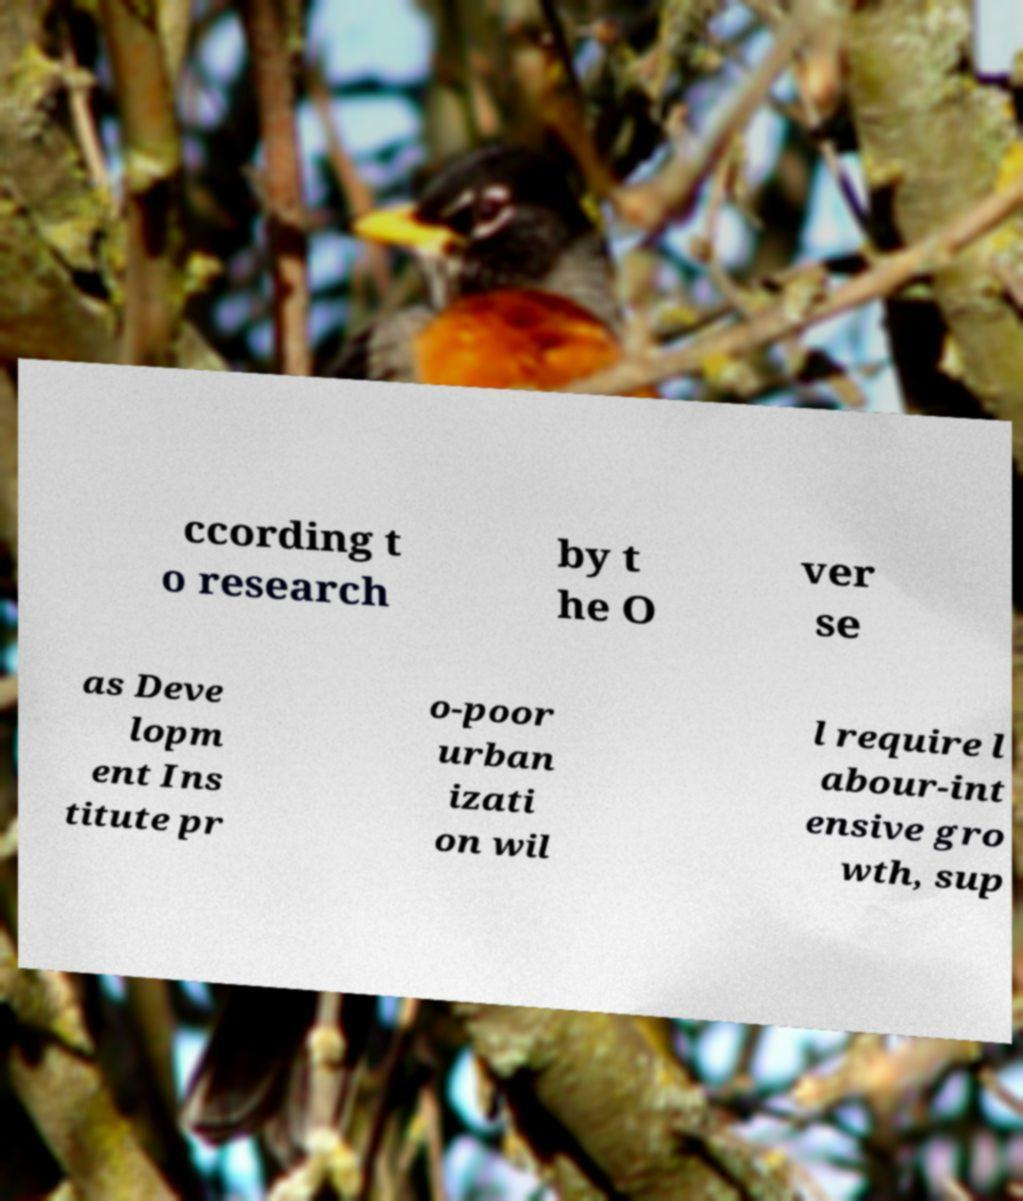Could you assist in decoding the text presented in this image and type it out clearly? ccording t o research by t he O ver se as Deve lopm ent Ins titute pr o-poor urban izati on wil l require l abour-int ensive gro wth, sup 